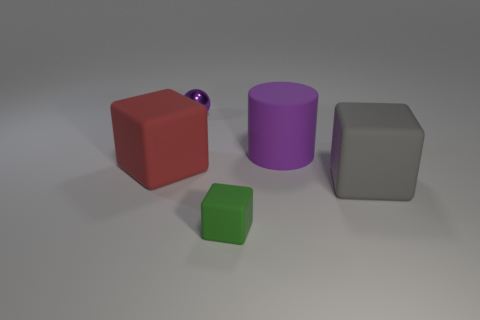Add 3 big cylinders. How many objects exist? 8 Subtract all cubes. How many objects are left? 2 Add 5 big cyan cylinders. How many big cyan cylinders exist? 5 Subtract 1 green cubes. How many objects are left? 4 Subtract all green things. Subtract all gray matte cubes. How many objects are left? 3 Add 1 small green rubber things. How many small green rubber things are left? 2 